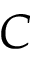<formula> <loc_0><loc_0><loc_500><loc_500>C</formula> 